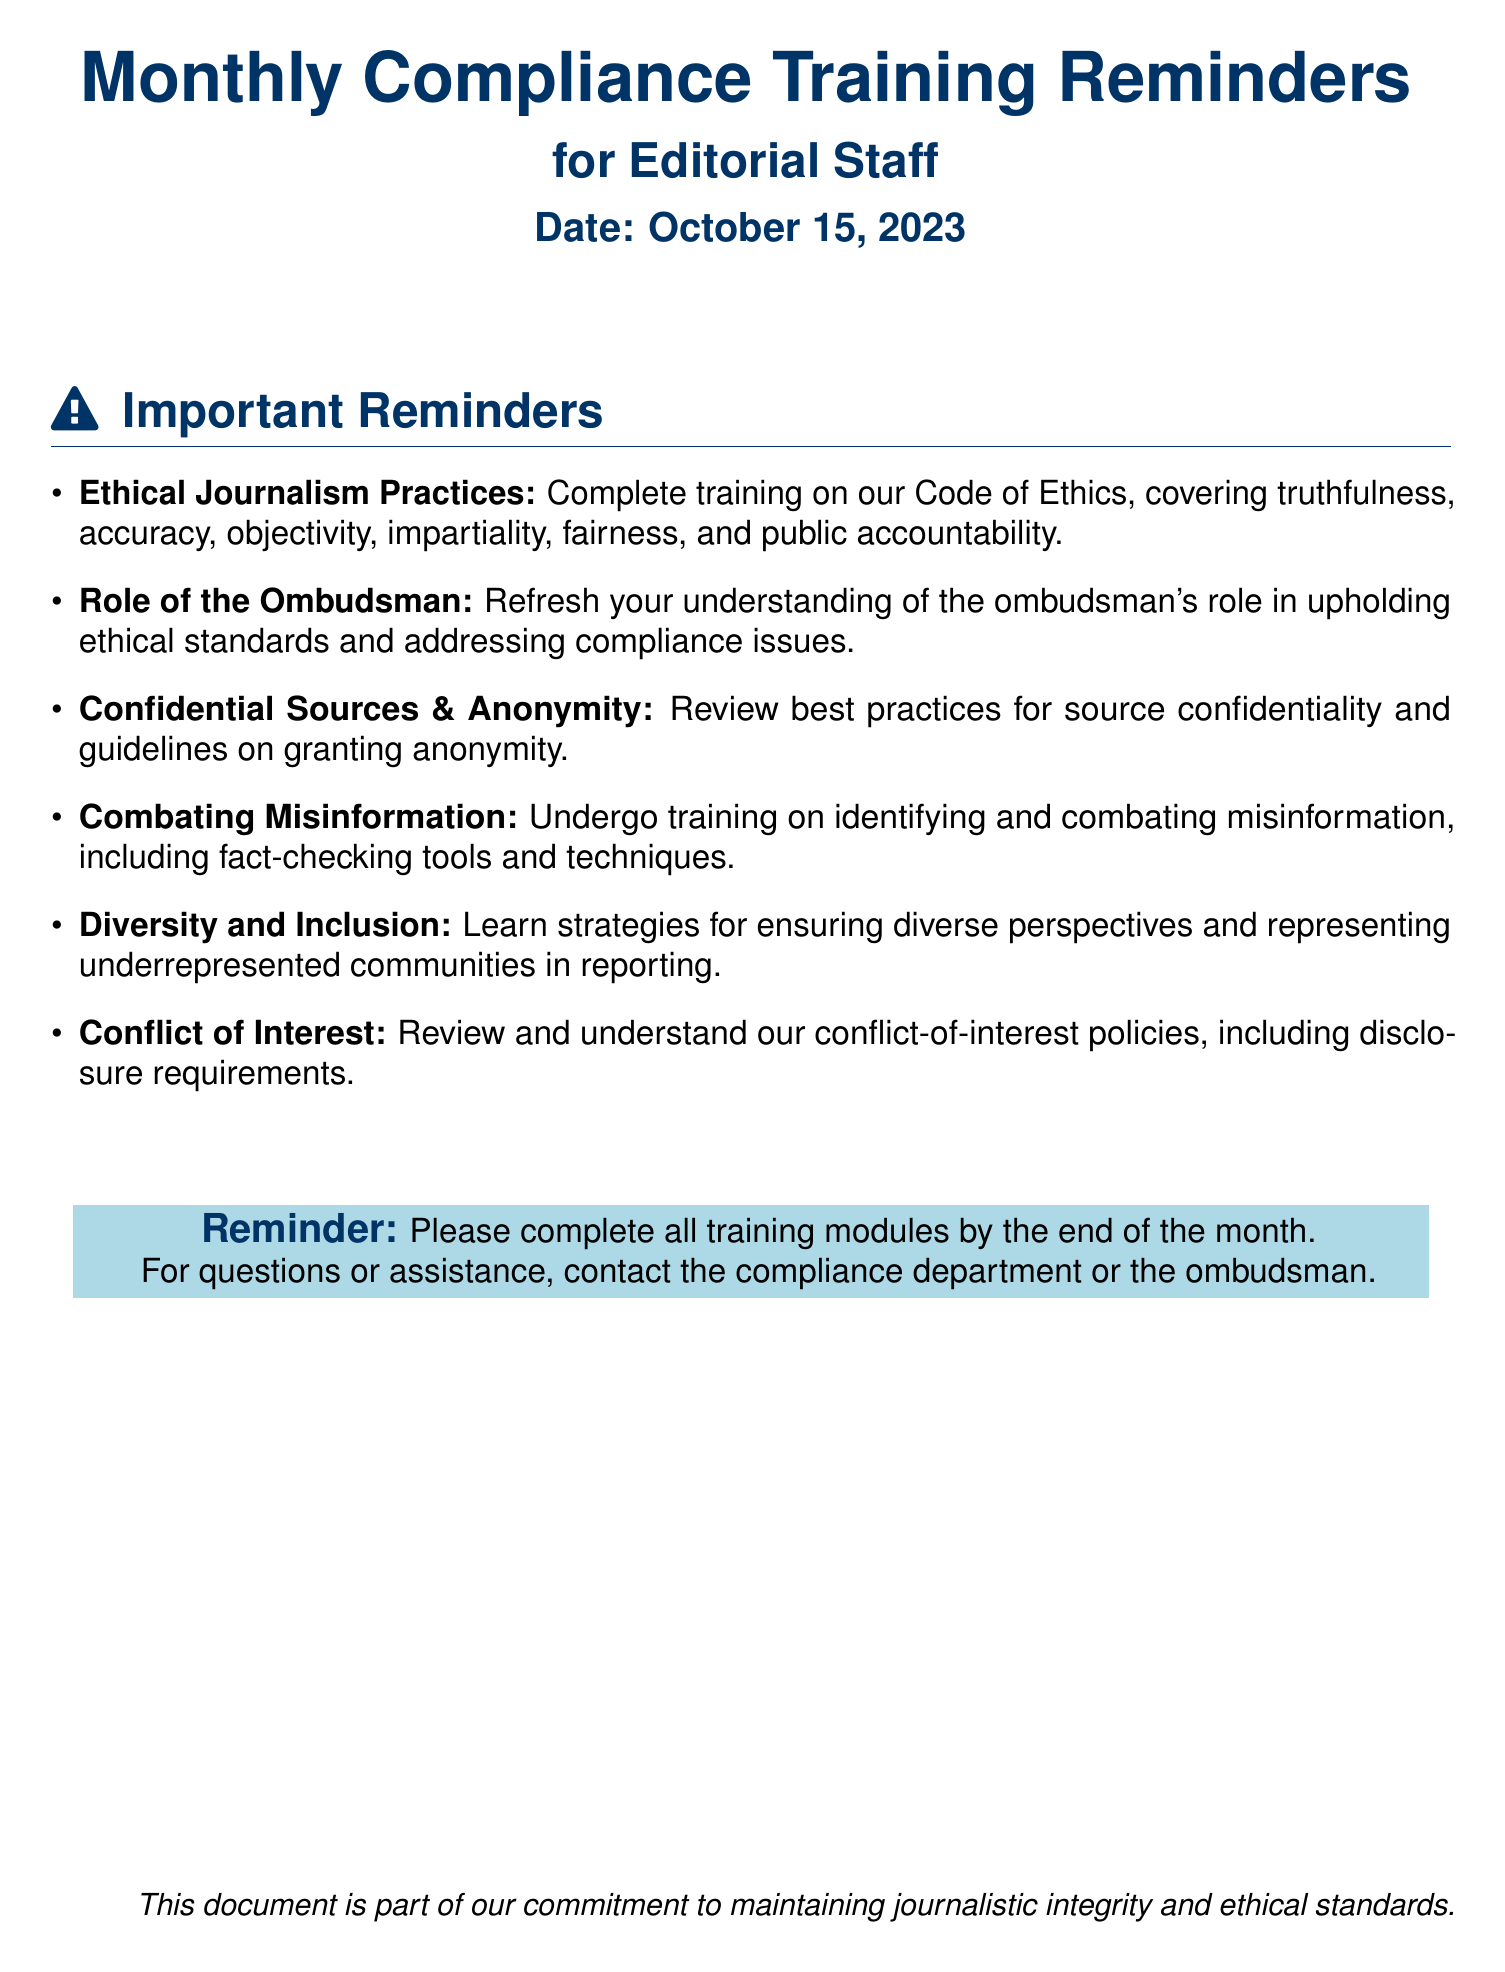What is the date of the document? The date is specified in the document header as the publication date of the reminders, which is outlined prominently.
Answer: October 15, 2023 What is the first training topic listed? The first training topic is the initial subject mentioned in the Important Reminders section, which highlights key areas for compliance training.
Answer: Ethical Journalism Practices How many training topics are mentioned? The total number of topics is determined by counting the bullet points provided in the Important Reminders section.
Answer: Six What is the main focus of the ombudsman's role as highlighted in the document? The role is elaborated upon in the second bullet point, indicating responsibility surrounding ethical standards and compliance.
Answer: Upholding ethical standards What should editorial staff review regarding sources? The list includes specific guidelines and best practices that are critical for maintaining ethical journalism involving sources.
Answer: Confidential Sources & Anonymity What must be completed by the end of the month? The reminder emphasizes the completion of essential training modules as a deadline for editorial staff's compliance efforts.
Answer: All training modules 